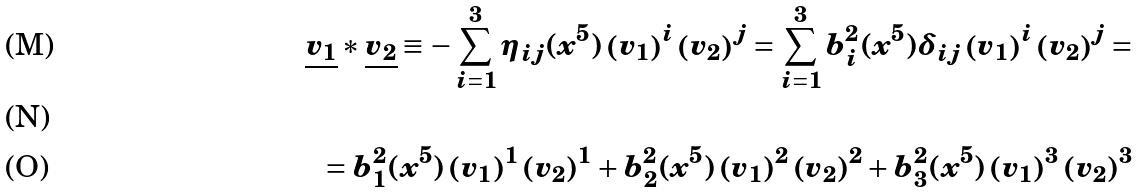<formula> <loc_0><loc_0><loc_500><loc_500>\underline { v _ { 1 } } \ast \underline { v _ { 2 } } \equiv - \sum _ { i = 1 } ^ { 3 } \eta _ { i j } ( x ^ { 5 } ) \left ( v _ { 1 } \right ) ^ { i } \left ( v _ { 2 } \right ) ^ { j } = \sum _ { i = 1 } ^ { 3 } b _ { i } ^ { 2 } ( x ^ { 5 } ) \delta _ { i j } \left ( v _ { 1 } \right ) ^ { i } \left ( v _ { 2 } \right ) ^ { j } = \\ \\ = b _ { 1 } ^ { 2 } ( x ^ { 5 } ) \left ( v _ { 1 } \right ) ^ { 1 } \left ( v _ { 2 } \right ) ^ { 1 } + b _ { 2 } ^ { 2 } ( x ^ { 5 } ) \left ( v _ { 1 } \right ) ^ { 2 } \left ( v _ { 2 } \right ) ^ { 2 } + b _ { 3 } ^ { 2 } ( x ^ { 5 } ) \left ( v _ { 1 } \right ) ^ { 3 } \left ( v _ { 2 } \right ) ^ { 3 }</formula> 